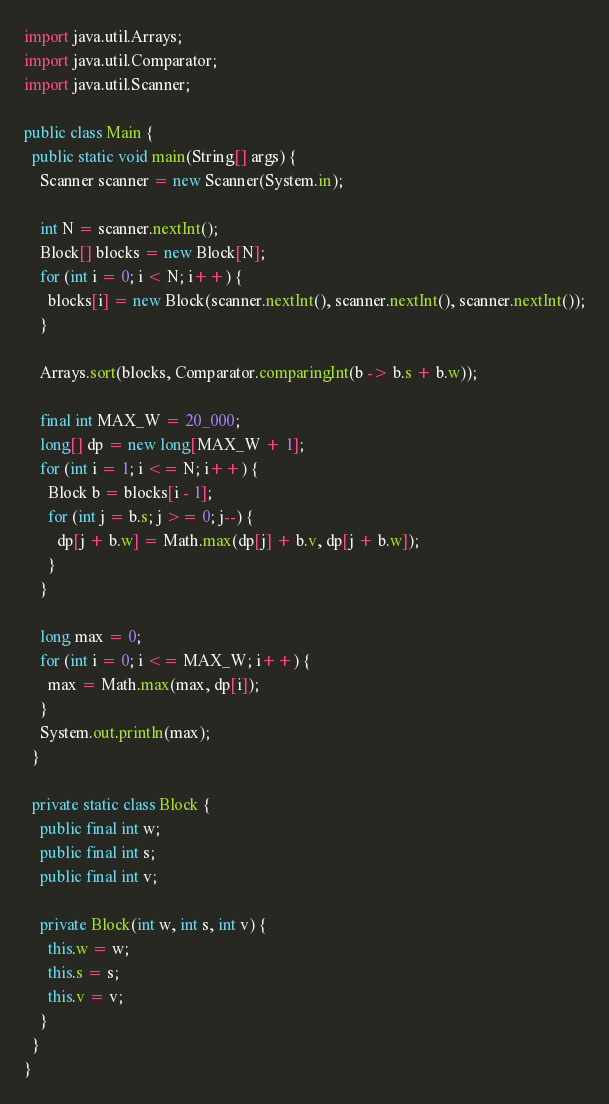<code> <loc_0><loc_0><loc_500><loc_500><_Java_>import java.util.Arrays;
import java.util.Comparator;
import java.util.Scanner;

public class Main {
  public static void main(String[] args) {
    Scanner scanner = new Scanner(System.in);

    int N = scanner.nextInt();
    Block[] blocks = new Block[N];
    for (int i = 0; i < N; i++) {
      blocks[i] = new Block(scanner.nextInt(), scanner.nextInt(), scanner.nextInt());
    }

    Arrays.sort(blocks, Comparator.comparingInt(b -> b.s + b.w));

    final int MAX_W = 20_000;
    long[] dp = new long[MAX_W + 1];
    for (int i = 1; i <= N; i++) {
      Block b = blocks[i - 1];
      for (int j = b.s; j >= 0; j--) {
        dp[j + b.w] = Math.max(dp[j] + b.v, dp[j + b.w]);
      }
    }

    long max = 0;
    for (int i = 0; i <= MAX_W; i++) {
      max = Math.max(max, dp[i]);
    }
    System.out.println(max);
  }

  private static class Block {
    public final int w;
    public final int s;
    public final int v;

    private Block(int w, int s, int v) {
      this.w = w;
      this.s = s;
      this.v = v;
    }
  }
}
</code> 